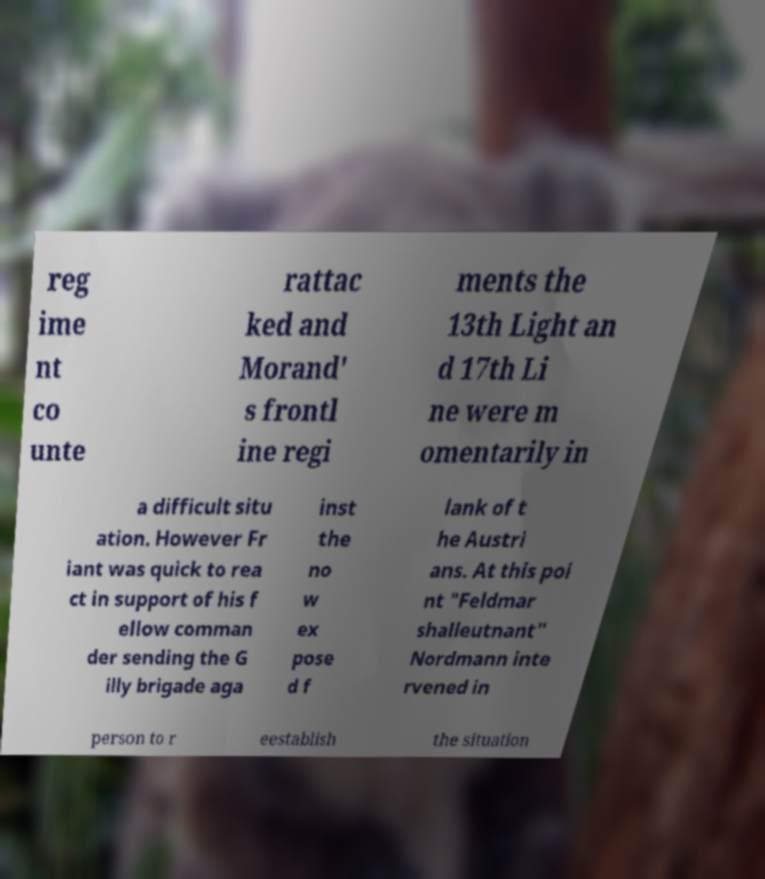There's text embedded in this image that I need extracted. Can you transcribe it verbatim? reg ime nt co unte rattac ked and Morand' s frontl ine regi ments the 13th Light an d 17th Li ne were m omentarily in a difficult situ ation. However Fr iant was quick to rea ct in support of his f ellow comman der sending the G illy brigade aga inst the no w ex pose d f lank of t he Austri ans. At this poi nt "Feldmar shalleutnant" Nordmann inte rvened in person to r eestablish the situation 